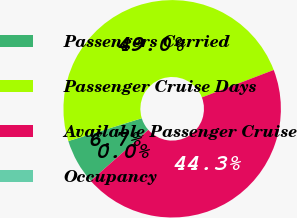<chart> <loc_0><loc_0><loc_500><loc_500><pie_chart><fcel>Passengers Carried<fcel>Passenger Cruise Days<fcel>Available Passenger Cruise<fcel>Occupancy<nl><fcel>6.73%<fcel>48.99%<fcel>44.28%<fcel>0.0%<nl></chart> 